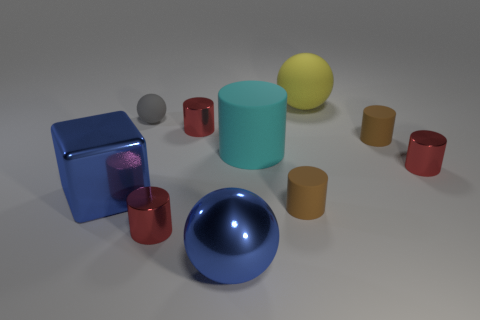Is there any other thing that has the same shape as the tiny gray rubber object? Yes, the small red object near the front of the image shares a similar cylindrical shape with the tiny gray rubber object, although their sizes and colors differ. 